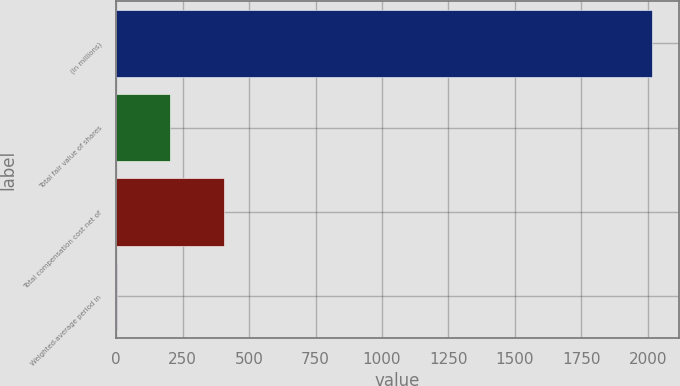Convert chart to OTSL. <chart><loc_0><loc_0><loc_500><loc_500><bar_chart><fcel>(In millions)<fcel>Total fair value of shares<fcel>Total compensation cost net of<fcel>Weighted-average period in<nl><fcel>2016<fcel>203.4<fcel>404.8<fcel>2<nl></chart> 